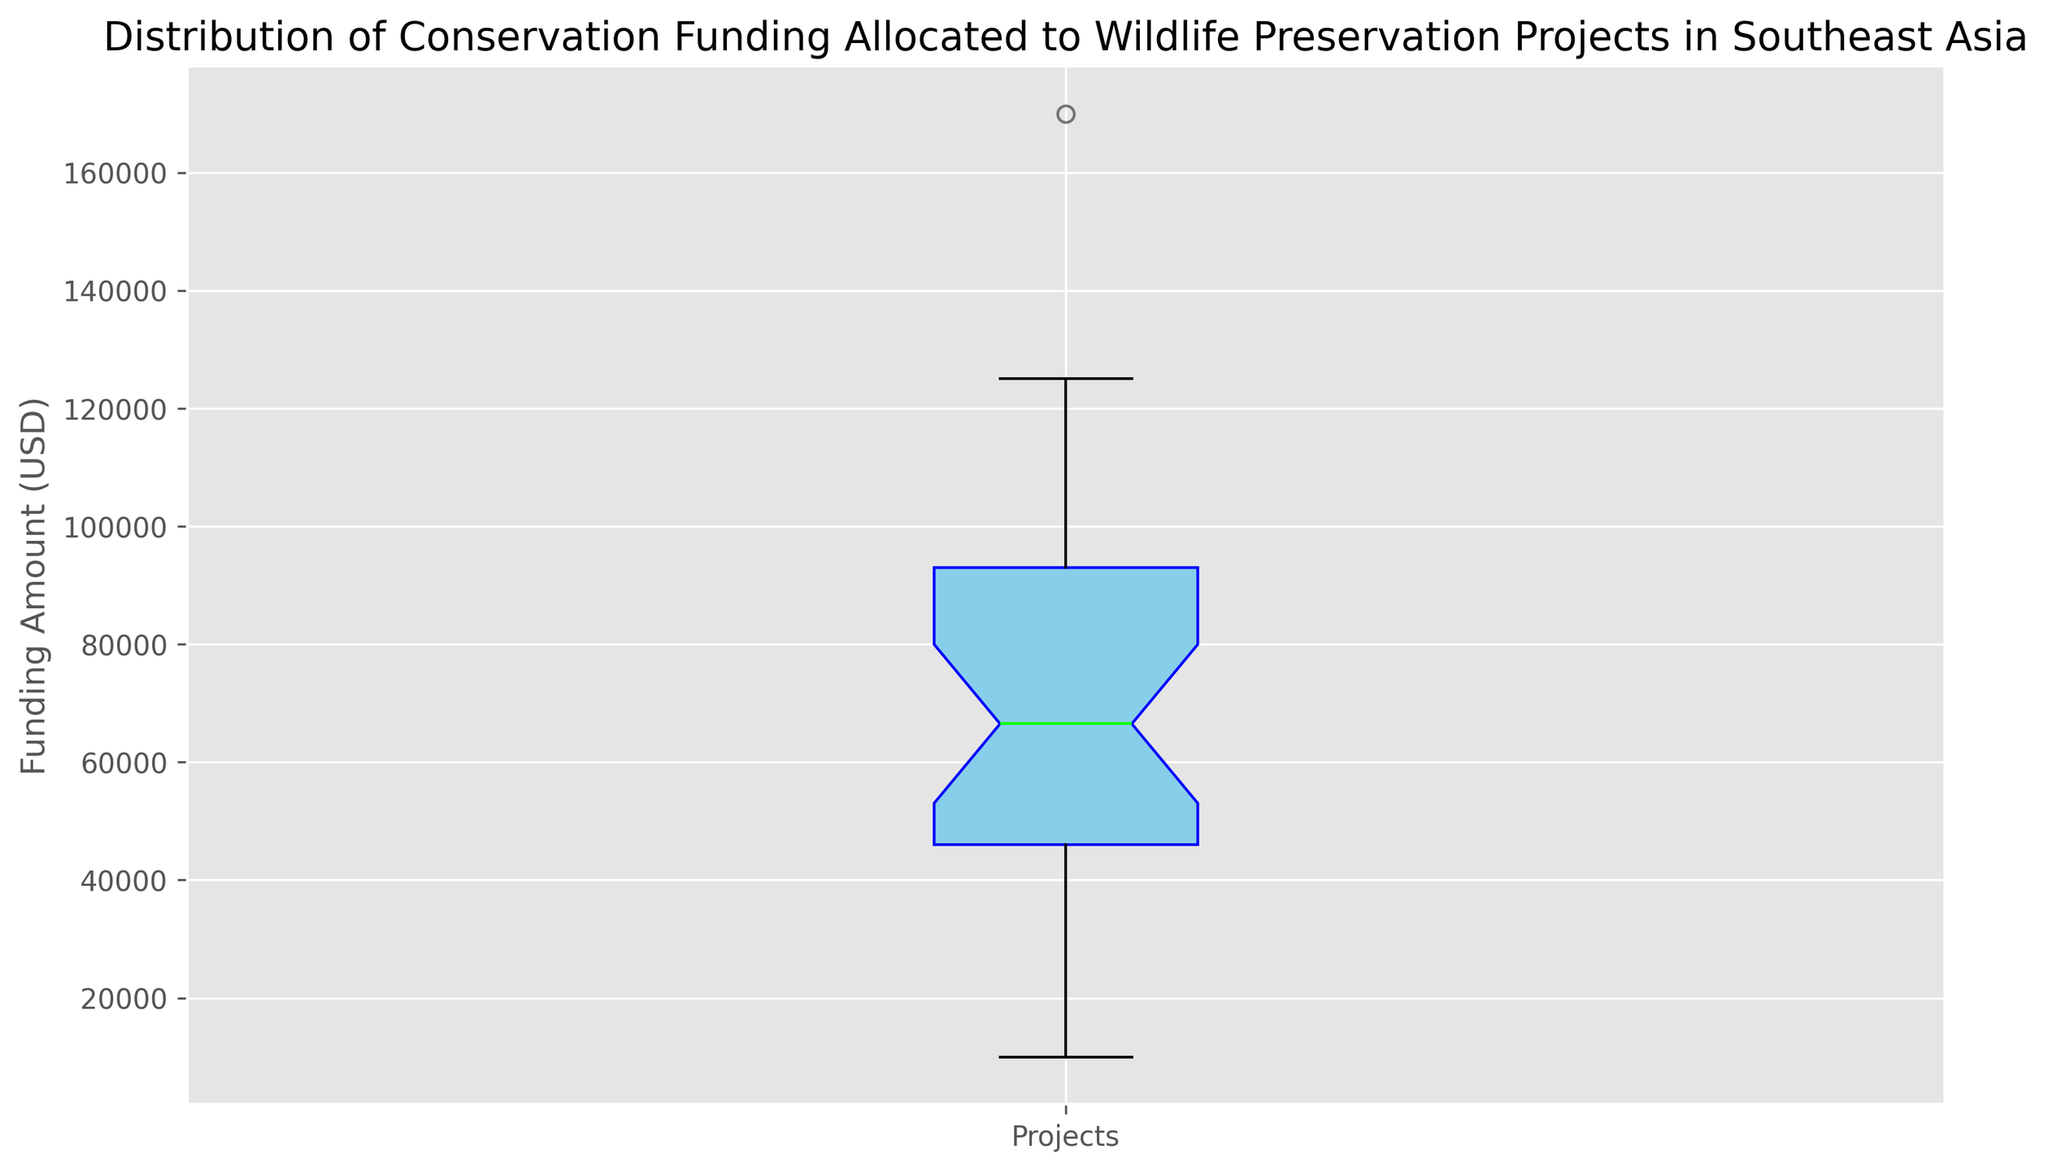What is the median funding amount for these wildlife preservation projects? The median is marked by the lime line within the box. From the box plot, the median funding amount for the projects is placed approximately at $70,000.
Answer: $70,000 What is the range of the conservation funding? The range is the difference between the maximum and minimum values. From the plot, the minimum value is around $10,000 and the maximum is around $170,000. The range is $170,000 - $10,000 = $160,000.
Answer: $160,000 What is the interquartile range (IQR) of the project's funding amounts? The interquartile range is the difference between the third quartile (Q3, the top of the box) and the first quartile (Q1, the bottom of the box). The approximate values from the box plot are Q3 at $100,000 and Q1 at $40,000, so IQR = $100,000 - $40,000 = $60,000.
Answer: $60,000 How many projects fall within the interquartile range (IQR)? The IQR represents the funding amounts where the middle 50% of the data lies (25th percentile to 75th percentile). Since there are 30 projects total, the middle 50% quantifies to 15 projects.
Answer: 15 projects What do the whiskers on the box plot represent? The whiskers indicate the spread of the data beyond the interquartile range (IQR) up to the points that are not outliers. The extent of the whiskers typically shows the maximum and minimum values of the data within 1.5 * IQR from the quartiles.
Answer: Spread of data beyond IQR What do the outliers indicate in this context? The red circles outside the whiskers represent the outliers, which are the projects with funding amounts significantly higher or lower than the rest of the data. These might indicate special high-interest projects or underfunded ones.
Answer: Projects with significantly higher or lower funding amounts Is the data skewed, and if so, in which direction? Data skewness can be inferred from the symmetry of the box plot. If the median is closer to the bottom of the box and the top whisker is longer, it indicates positive (right) skewness. Here, the plot shows right skewness as the whisker and outlier are more extended on the higher end.
Answer: Right skewed What is the effect of the outliers on the mean funding amount? Outliers tend to pull the mean towards them. Given the high outlier at about $170,000, the mean funding amount is likely higher than it would be in its absence. This positively skews the average.
Answer: Mean is positively skewed What is the funding amount at the 75th percentile? The 75th percentile or third quartile (Q3) is the top of the box. From the figure, it approximates to $100,000.
Answer: $100,000 How does the data distribution affect the interpretation of funding requirements for future projects? With a wide range and significant outliers, this distribution suggests funding variability. Organizing future funding necessitates understanding that many projects fall between a specific middle range ($40,000-$100,000), but a few will require substantially more resources, highlighting the need for flexible budgeting.
Answer: Flexible budgeting based on variable funding needs 